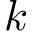<formula> <loc_0><loc_0><loc_500><loc_500>k</formula> 